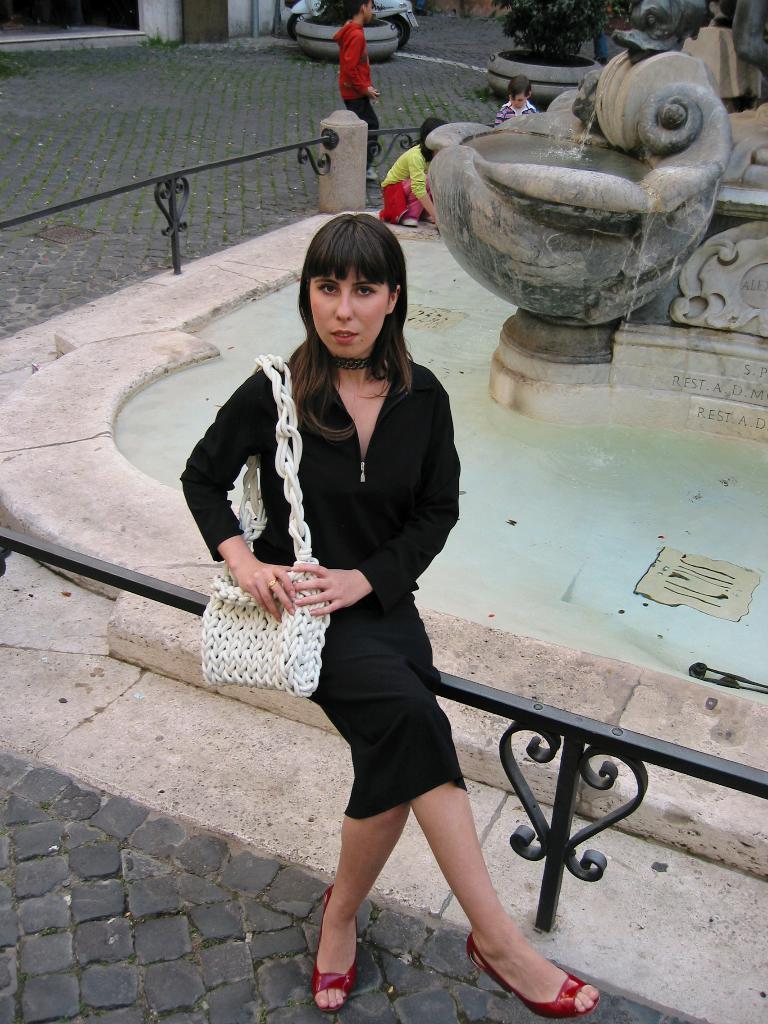In one or two sentences, can you explain what this image depicts? In this image we can see a woman sitting on a metal fence and carry a bag. Behind the woman we can see a fountain and few persons. At the top we can see houseplants, a vehicle and wall of a building. 